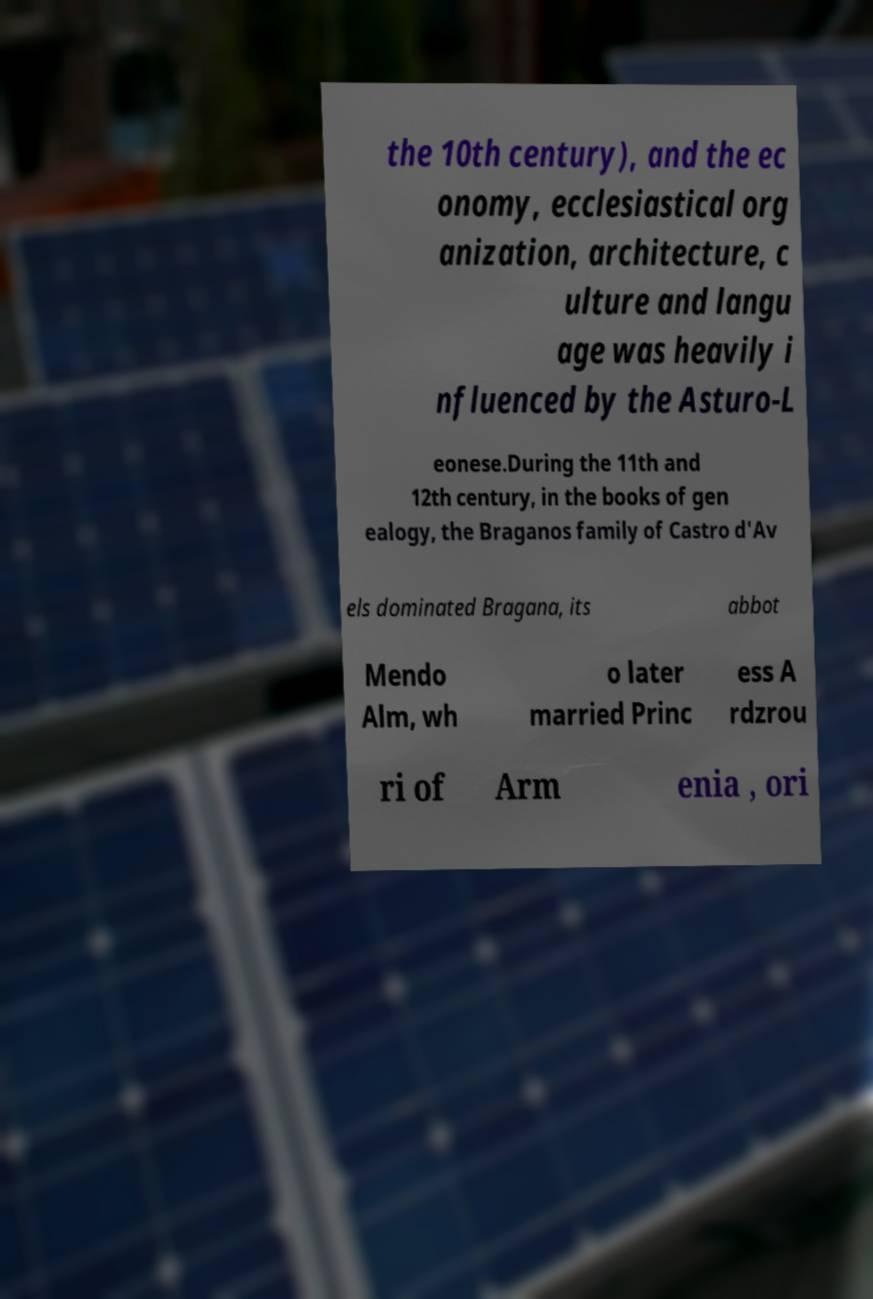I need the written content from this picture converted into text. Can you do that? the 10th century), and the ec onomy, ecclesiastical org anization, architecture, c ulture and langu age was heavily i nfluenced by the Asturo-L eonese.During the 11th and 12th century, in the books of gen ealogy, the Braganos family of Castro d'Av els dominated Bragana, its abbot Mendo Alm, wh o later married Princ ess A rdzrou ri of Arm enia , ori 